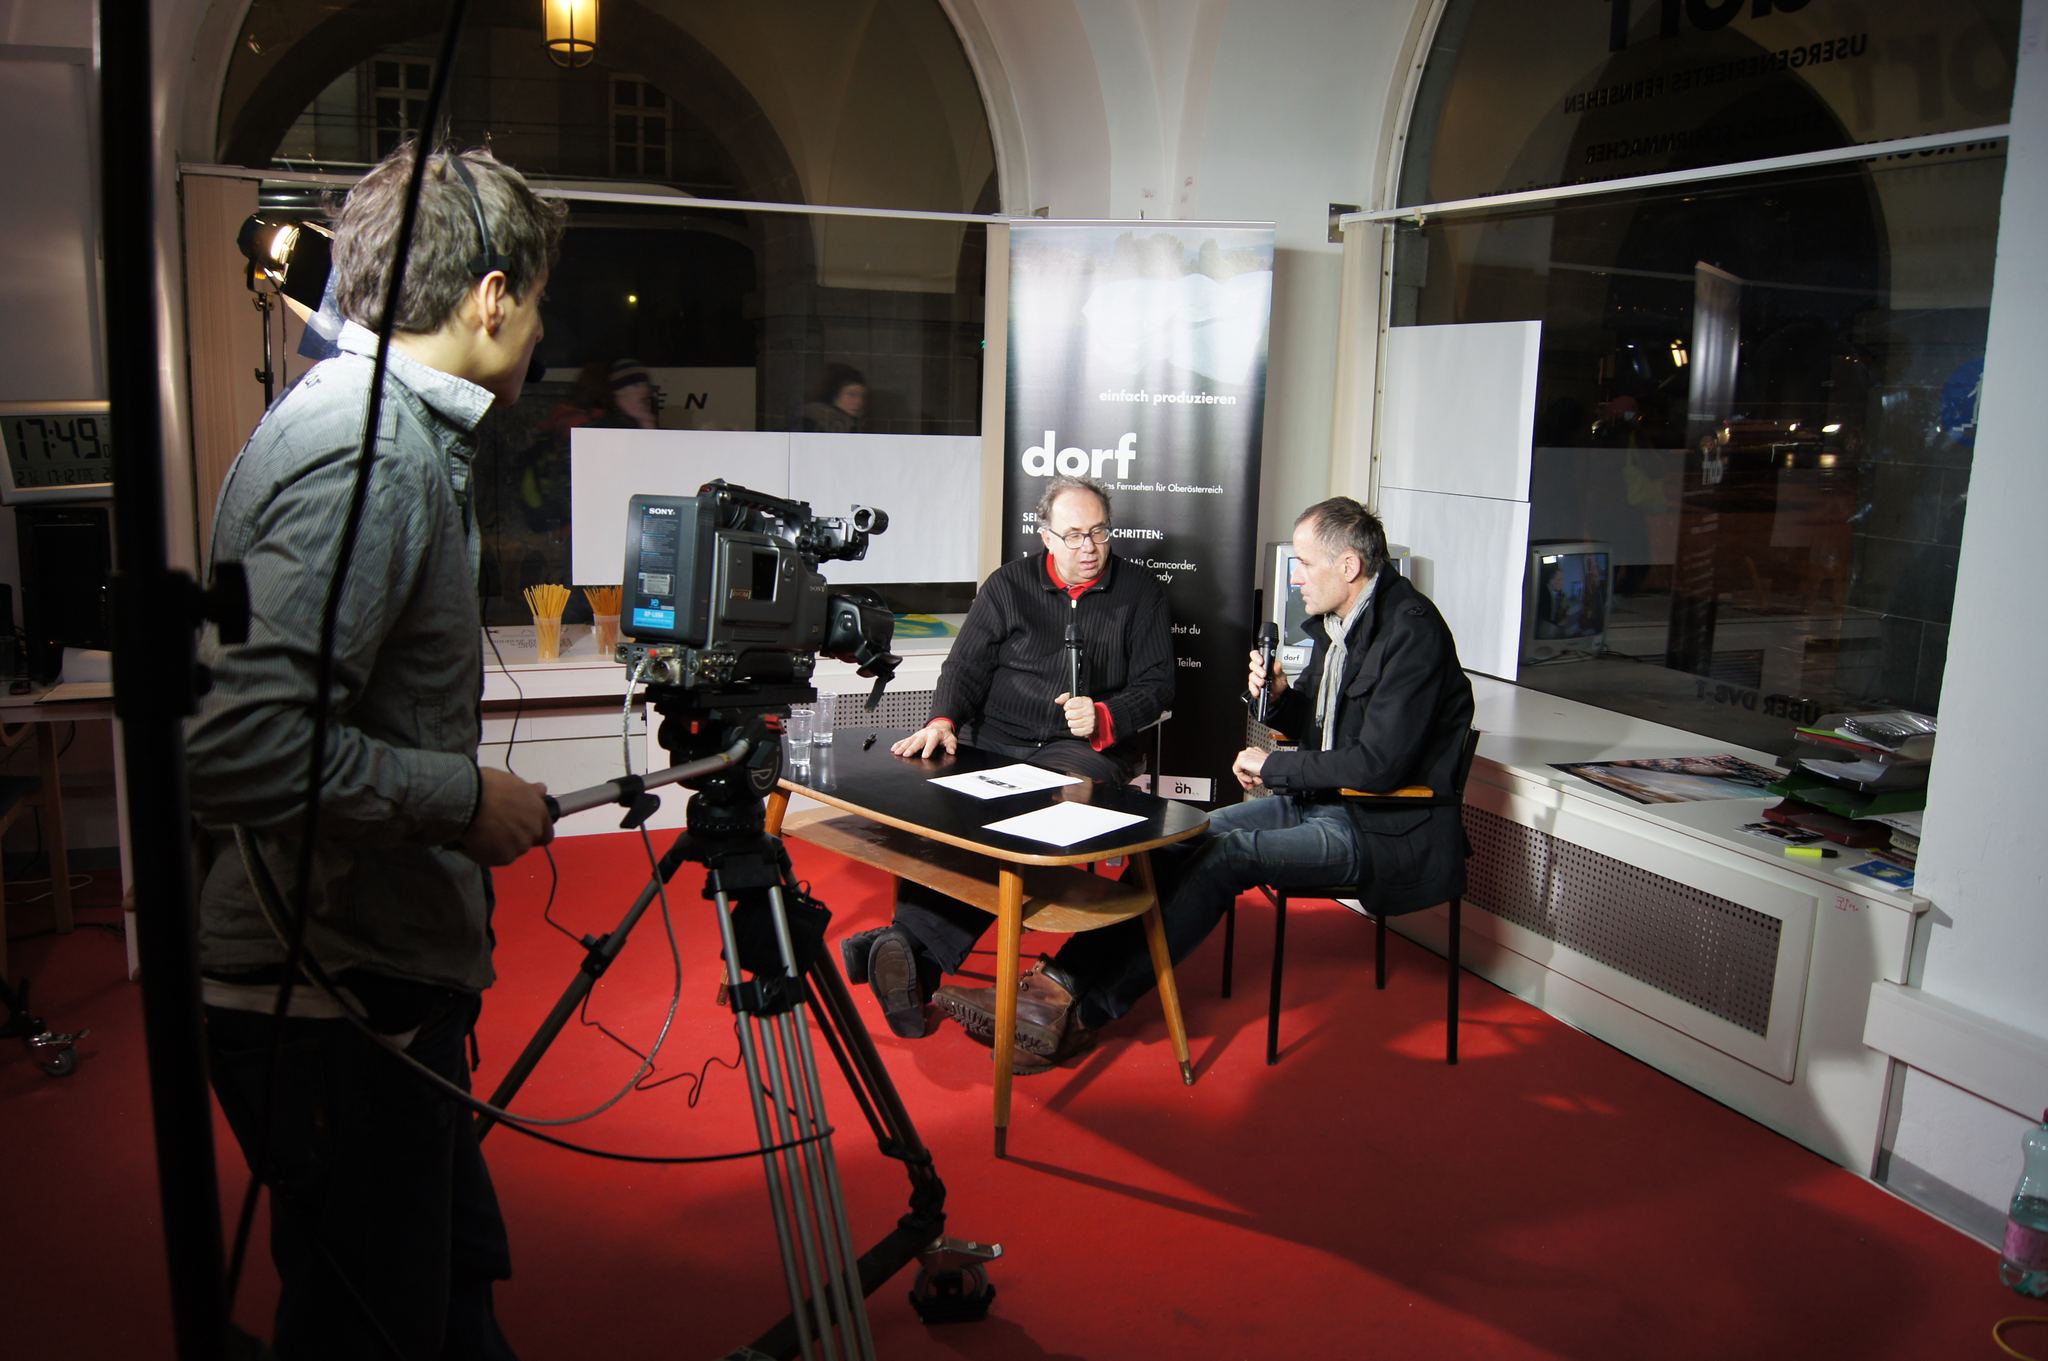How would you summarize this image in a sentence or two? There are two persons sitting on chair. There is a table in front of them. On the table there are papers. Two persons are holding mics. And there is a person wearing shirt. He is holding video camera. There is a banner in the background. And a light is there. On the floor there is a red carpet. Behind there is a building. 